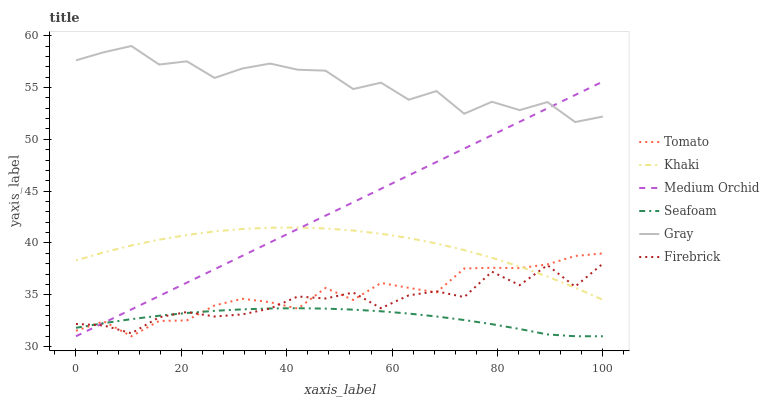Does Seafoam have the minimum area under the curve?
Answer yes or no. Yes. Does Gray have the maximum area under the curve?
Answer yes or no. Yes. Does Khaki have the minimum area under the curve?
Answer yes or no. No. Does Khaki have the maximum area under the curve?
Answer yes or no. No. Is Medium Orchid the smoothest?
Answer yes or no. Yes. Is Gray the roughest?
Answer yes or no. Yes. Is Khaki the smoothest?
Answer yes or no. No. Is Khaki the roughest?
Answer yes or no. No. Does Tomato have the lowest value?
Answer yes or no. Yes. Does Khaki have the lowest value?
Answer yes or no. No. Does Gray have the highest value?
Answer yes or no. Yes. Does Khaki have the highest value?
Answer yes or no. No. Is Tomato less than Gray?
Answer yes or no. Yes. Is Gray greater than Khaki?
Answer yes or no. Yes. Does Medium Orchid intersect Gray?
Answer yes or no. Yes. Is Medium Orchid less than Gray?
Answer yes or no. No. Is Medium Orchid greater than Gray?
Answer yes or no. No. Does Tomato intersect Gray?
Answer yes or no. No. 